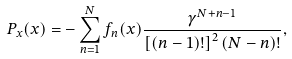Convert formula to latex. <formula><loc_0><loc_0><loc_500><loc_500>P _ { x } ( x ) = - \sum _ { n = 1 } ^ { N } f _ { n } ( x ) \frac { \gamma ^ { N + n - 1 } } { \left [ ( n - 1 ) ! \right ] ^ { 2 } ( N - n ) ! } ,</formula> 